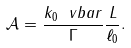Convert formula to latex. <formula><loc_0><loc_0><loc_500><loc_500>\mathcal { A } = \frac { k _ { 0 } \ v b a r } { \Gamma } \frac { L } { \ell _ { 0 } } .</formula> 